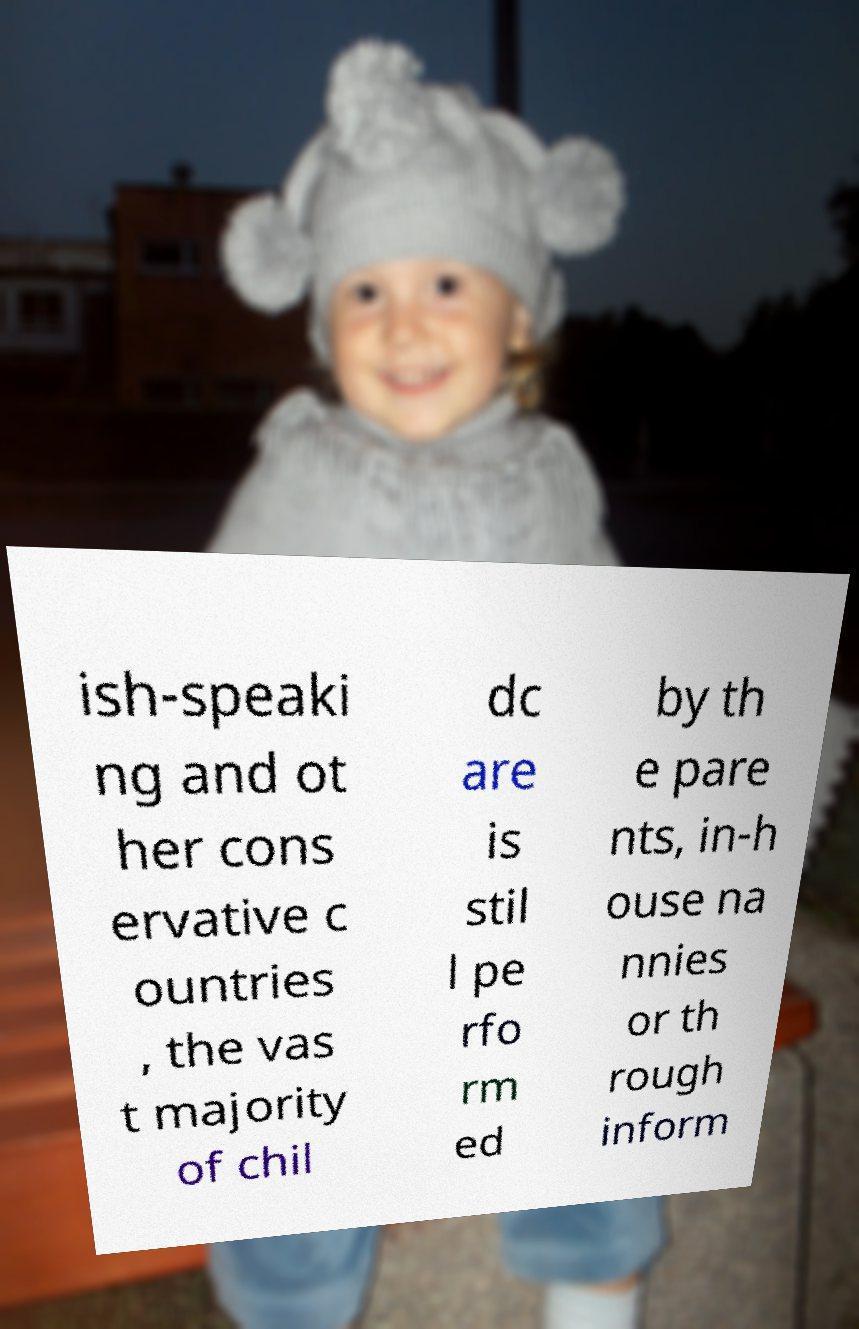Can you read and provide the text displayed in the image?This photo seems to have some interesting text. Can you extract and type it out for me? ish-speaki ng and ot her cons ervative c ountries , the vas t majority of chil dc are is stil l pe rfo rm ed by th e pare nts, in-h ouse na nnies or th rough inform 